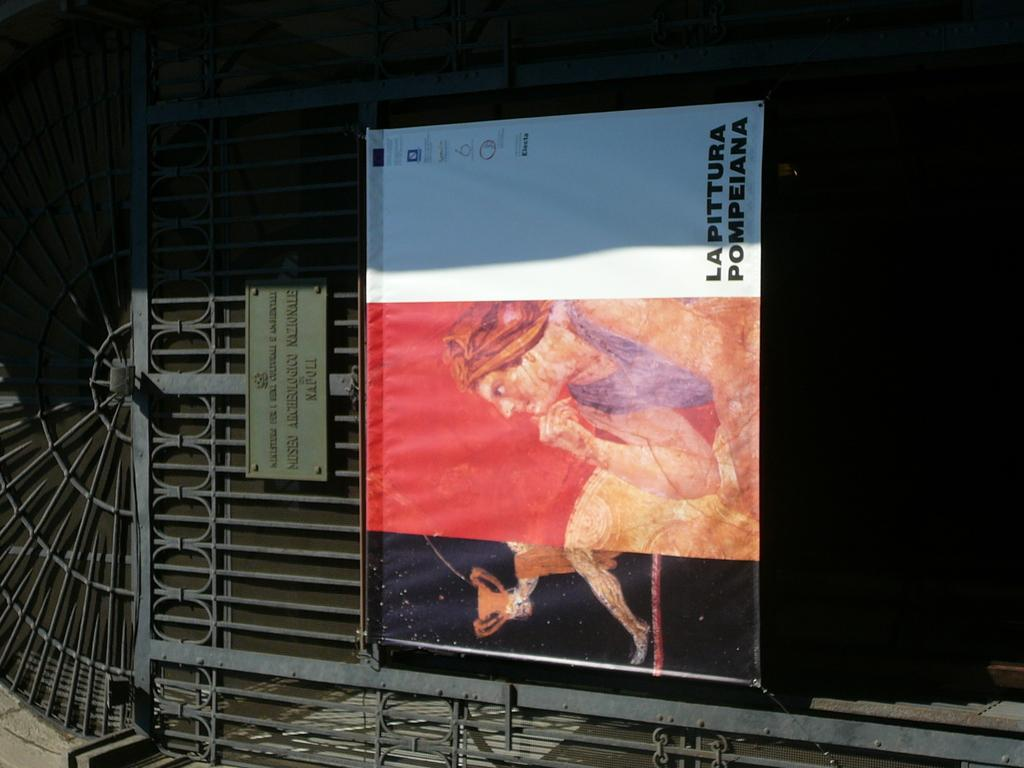<image>
Offer a succinct explanation of the picture presented. a poster that says 'lapittura pompeiana' on it 